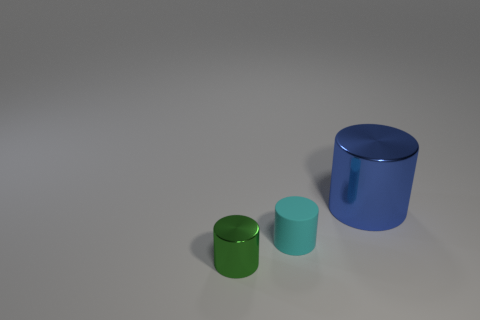There is a metallic object in front of the blue metallic object; what is its size?
Offer a very short reply. Small. Is there a large blue cube that has the same material as the large object?
Your answer should be compact. No. Is the big blue object made of the same material as the small green cylinder?
Keep it short and to the point. Yes. There is a metal cylinder that is the same size as the rubber object; what is its color?
Make the answer very short. Green. What number of other things are there of the same shape as the big blue thing?
Make the answer very short. 2. There is a cyan matte object; is its size the same as the metallic thing left of the big cylinder?
Provide a succinct answer. Yes. What number of things are small cyan rubber objects or tiny green cylinders?
Offer a very short reply. 2. How many other things are there of the same size as the green thing?
Offer a terse response. 1. There is a rubber thing; does it have the same color as the metallic cylinder that is in front of the small rubber thing?
Your answer should be very brief. No. How many cubes are small rubber objects or small green metal things?
Give a very brief answer. 0. 